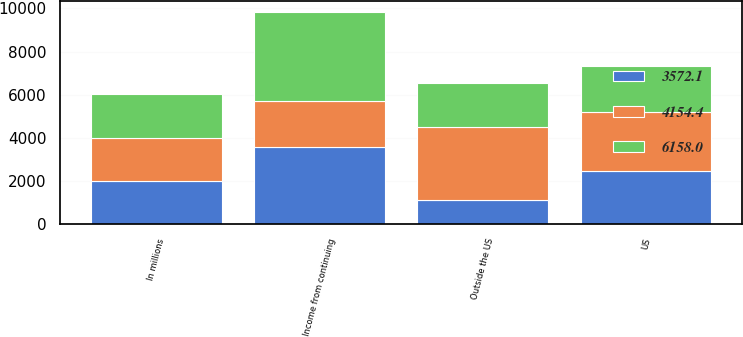Convert chart. <chart><loc_0><loc_0><loc_500><loc_500><stacked_bar_chart><ecel><fcel>In millions<fcel>US<fcel>Outside the US<fcel>Income from continuing<nl><fcel>4154.4<fcel>2008<fcel>2769.4<fcel>3388.6<fcel>2126.2<nl><fcel>3572.1<fcel>2007<fcel>2455<fcel>1117.1<fcel>3572.1<nl><fcel>6158<fcel>2006<fcel>2126.2<fcel>2028.2<fcel>4154.4<nl></chart> 